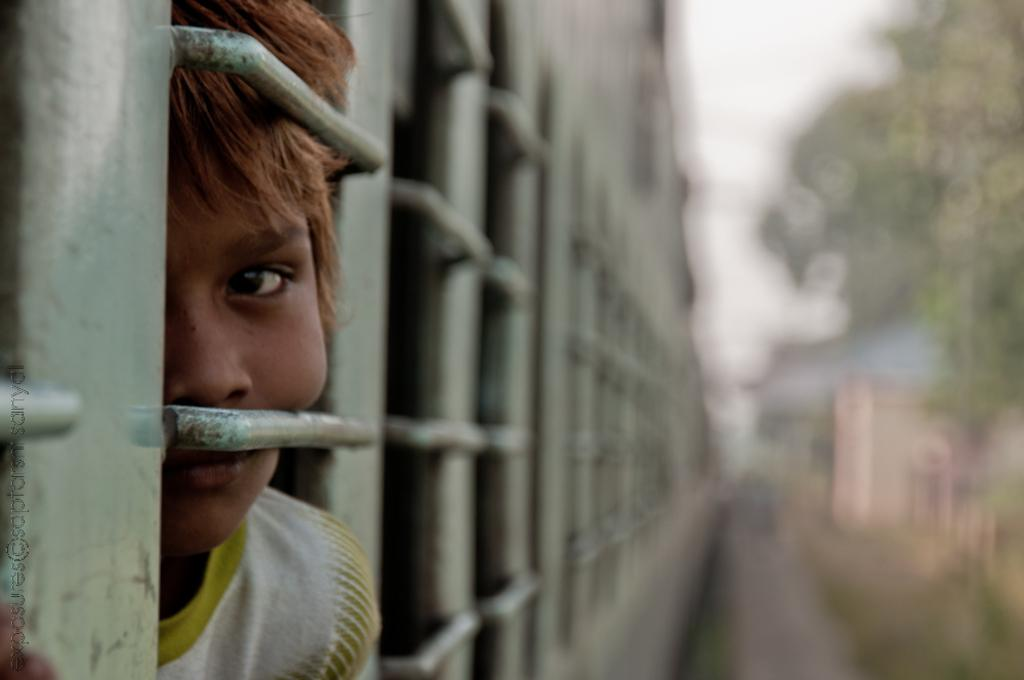What is the main subject in the foreground of the image? There is a kid in the foreground of the image. Where is the kid located? The kid is inside a train. Can you describe the kid's position in relation to the train? The kid is near a window on the left side. What can be observed about the right side of the image? The right side of the image is blurry. What type of cheese is being served to the kid in the image? There is no cheese present in the image; the kid is inside a train. Can you tell me which button the kid is pressing in the image? There is no button visible in the image; the kid is near a window on the left side. 